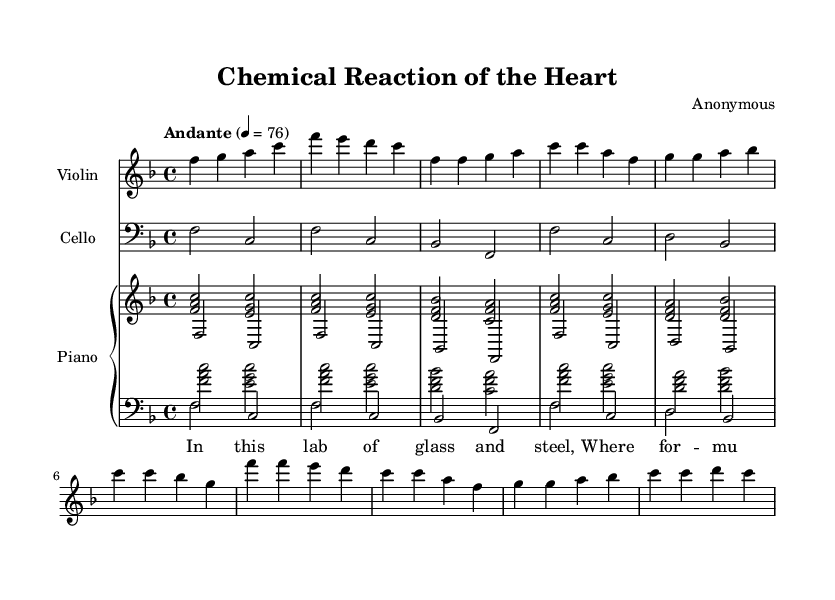What is the key signature of this music? The key signature shown on the staff indicates F major, which has one flat (B flat).
Answer: F major What is the time signature of this music? The time signature at the beginning of the score shows a 4/4, meaning there are four beats in each measure.
Answer: 4/4 What is the tempo indicated in this music? The tempo marking is "Andante", represented with a quarter note equals 76 beats per minute.
Answer: Andante What is the overarching theme of the lyrics presented? The lyrics suggest a romantic connection, making references to a laboratory setting, indicating emotions tied to chemistry and love.
Answer: Love in a laboratory Which instruments are featured in this piece? The score explicitly lists three instruments: Violin, Cello, and Piano.
Answer: Violin, Cello, Piano What is the dynamic marking for the piano section? While the explicit dynamics are not present in the code, typically, a romantic ballad such as this would often involve expressive dynamics, which might be implied in performance; thus, it's generally interpreted as 'mp' (mezzo-piano) or 'mf' (mezzo-forte).
Answer: Implicit dynamics What are the first two lines of the lyrics? The lyrics begin with "In this lab of glass and steel, Where formulas reveal their might".
Answer: In this lab of glass and steel, Where formulas reveal their might 